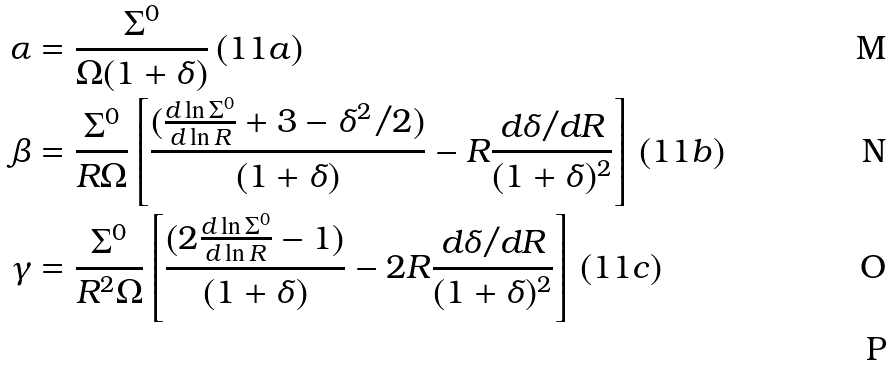Convert formula to latex. <formula><loc_0><loc_0><loc_500><loc_500>\alpha & = \frac { \Sigma ^ { 0 } } { \Omega ( 1 + \delta ) } \, ( 1 1 a ) \\ \beta & = \frac { \Sigma ^ { 0 } } { R \Omega } \left [ \frac { ( \frac { d \ln \Sigma ^ { 0 } } { d \ln R } + 3 - { \delta ^ { 2 } / 2 } ) } { ( 1 + \delta ) } - R \frac { d \delta / d R } { ( 1 + \delta ) ^ { 2 } } \right ] \, ( 1 1 b ) \\ \gamma & = \frac { \Sigma ^ { 0 } } { R ^ { 2 } \Omega } \left [ \frac { ( 2 \frac { d \ln \Sigma ^ { 0 } } { d \ln R } - 1 ) } { ( 1 + \delta ) } - 2 R \frac { d \delta / d R } { ( 1 + \delta ) ^ { 2 } } \right ] \, ( 1 1 c ) \\</formula> 